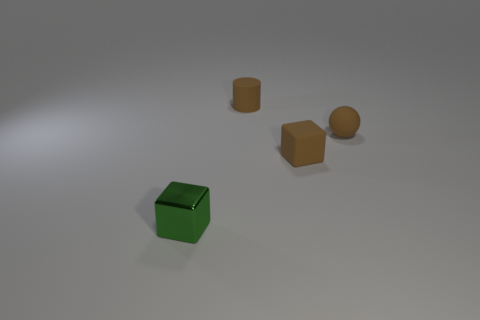Add 1 tiny shiny cubes. How many objects exist? 5 Subtract all green cubes. How many cubes are left? 1 Subtract all balls. How many objects are left? 3 Add 1 small gray shiny spheres. How many small gray shiny spheres exist? 1 Subtract 0 red cylinders. How many objects are left? 4 Subtract all green cylinders. Subtract all gray cubes. How many cylinders are left? 1 Subtract all brown matte spheres. Subtract all small brown cylinders. How many objects are left? 2 Add 3 tiny rubber spheres. How many tiny rubber spheres are left? 4 